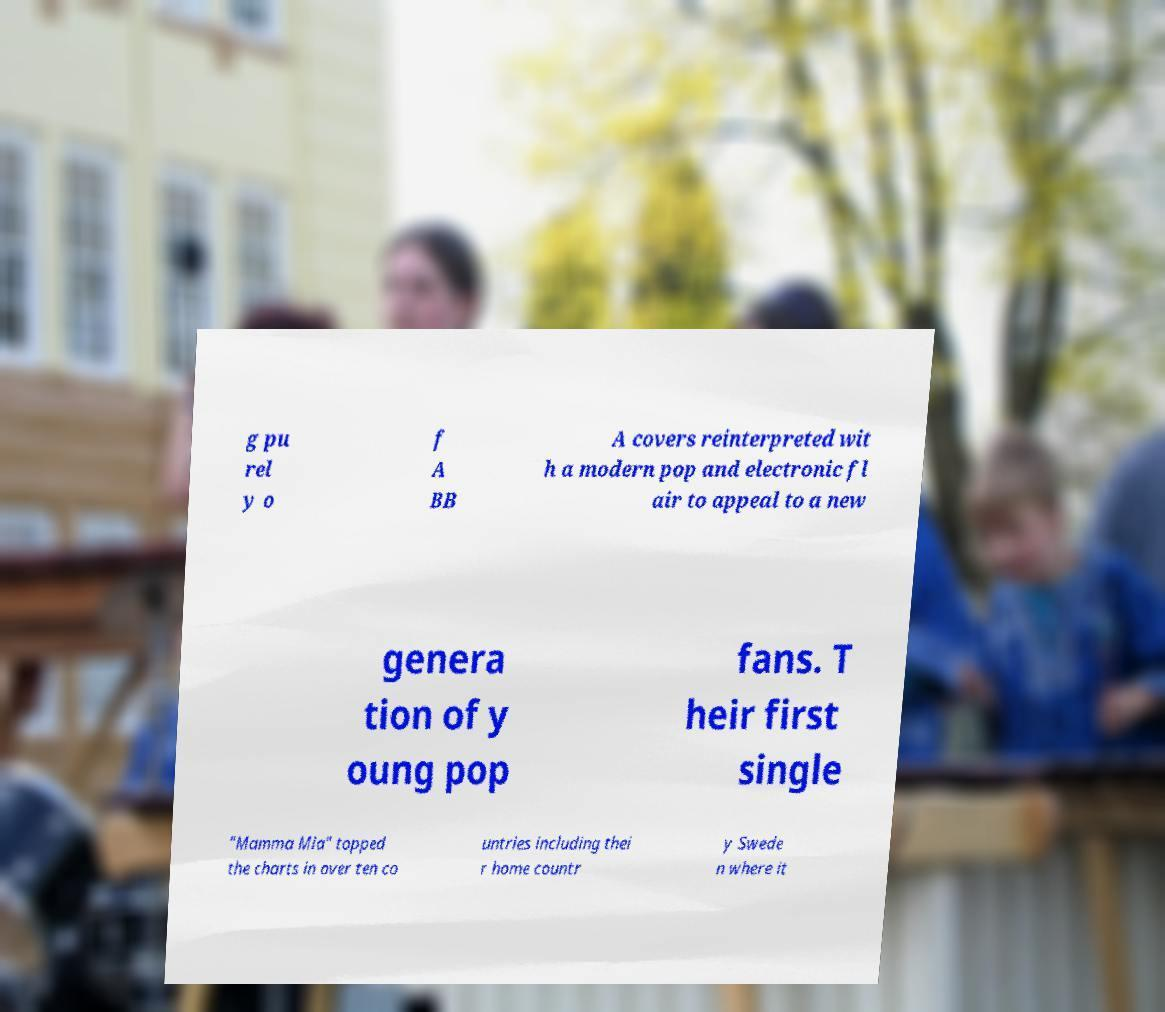I need the written content from this picture converted into text. Can you do that? g pu rel y o f A BB A covers reinterpreted wit h a modern pop and electronic fl air to appeal to a new genera tion of y oung pop fans. T heir first single "Mamma Mia" topped the charts in over ten co untries including thei r home countr y Swede n where it 